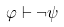<formula> <loc_0><loc_0><loc_500><loc_500>\varphi \vdash \neg \psi</formula> 